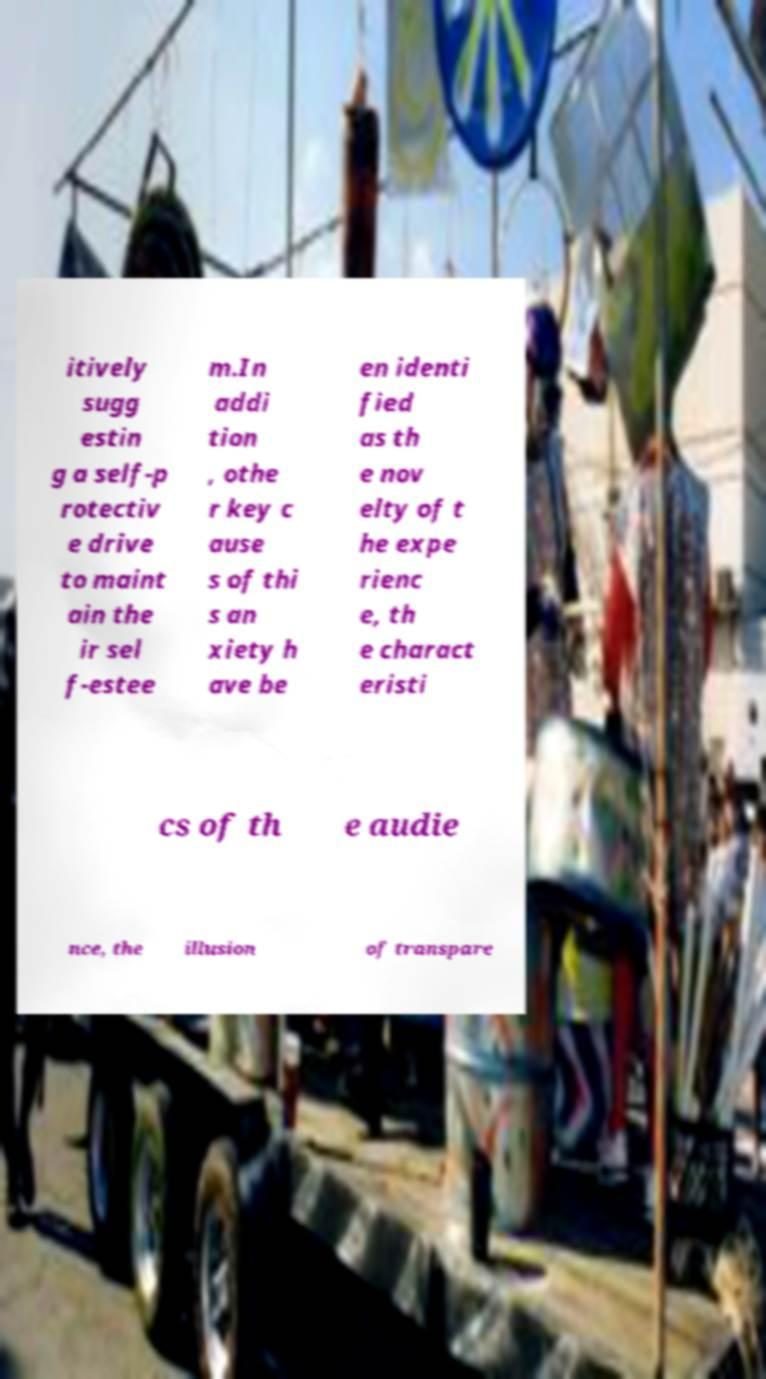Could you assist in decoding the text presented in this image and type it out clearly? itively sugg estin g a self-p rotectiv e drive to maint ain the ir sel f-estee m.In addi tion , othe r key c ause s of thi s an xiety h ave be en identi fied as th e nov elty of t he expe rienc e, th e charact eristi cs of th e audie nce, the illusion of transpare 